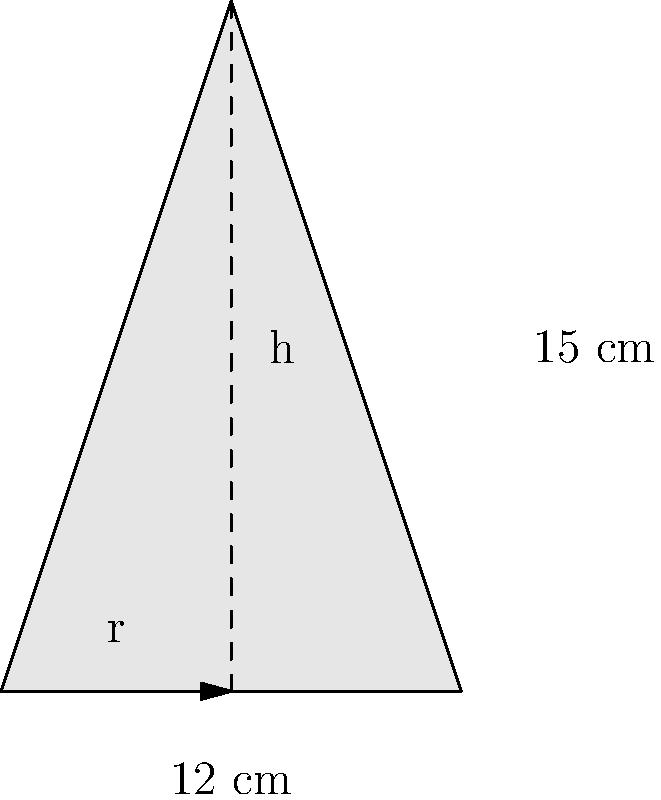In your kitchen, you have a conical sifter for flour with a slant height of 15 cm and a base diameter of 12 cm. What is the lateral surface area of this sifter? Round your answer to the nearest square centimeter. Let's approach this step-by-step:

1) First, we need to recall the formula for the lateral surface area of a cone:
   $$ A = \pi r s $$
   where $A$ is the lateral surface area, $r$ is the radius of the base, and $s$ is the slant height.

2) We're given the slant height ($s$) as 15 cm.

3) The diameter of the base is 12 cm, so the radius ($r$) is half of this:
   $$ r = 12 \div 2 = 6 \text{ cm} $$

4) Now we can plug these values into our formula:
   $$ A = \pi \times 6 \times 15 $$

5) Let's calculate this:
   $$ A = \pi \times 90 = 282.7433... \text{ cm}^2 $$

6) Rounding to the nearest square centimeter:
   $$ A \approx 283 \text{ cm}^2 $$

Therefore, the lateral surface area of the conical sifter is approximately 283 square centimeters.
Answer: 283 cm² 